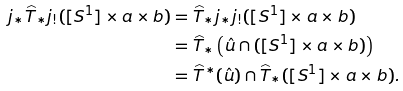Convert formula to latex. <formula><loc_0><loc_0><loc_500><loc_500>j _ { * } \widehat { T } _ { * } j _ { ! } ( [ S ^ { 1 } ] \times a \times b ) & = \widehat { T } _ { * } j _ { * } j _ { ! } ( [ S ^ { 1 } ] \times a \times b ) \\ & = \widehat { T } _ { * } \left ( \hat { u } \cap ( [ S ^ { 1 } ] \times a \times b ) \right ) \\ & = \widehat { T } ^ { * } ( \hat { u } ) \cap \widehat { T } _ { * } ( [ S ^ { 1 } ] \times a \times b ) .</formula> 